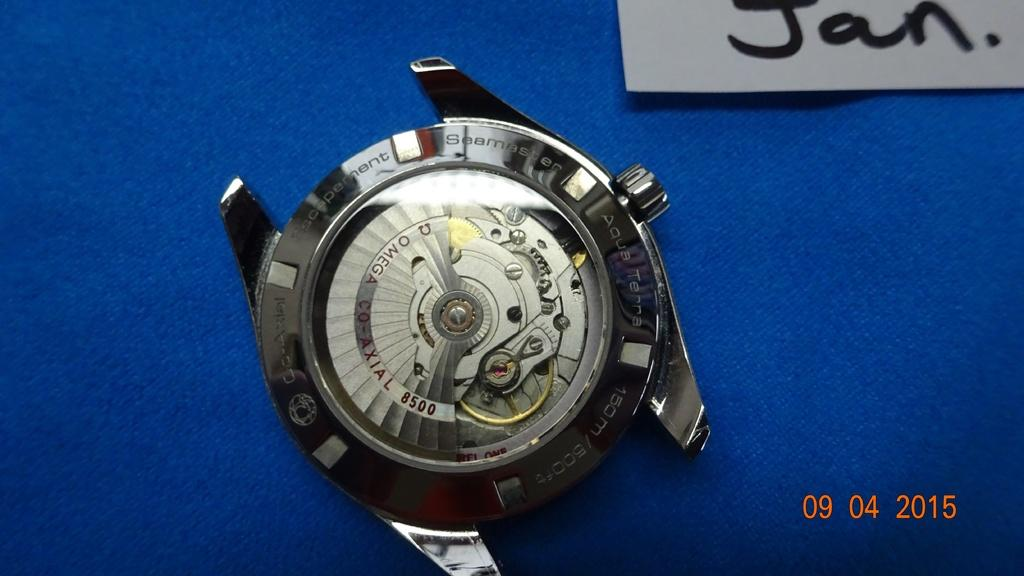Provide a one-sentence caption for the provided image. A watch is shown, with the month Jan. displayed in the top right. 